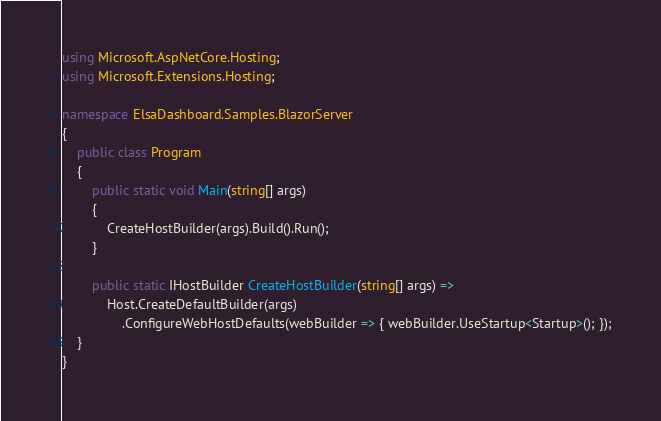Convert code to text. <code><loc_0><loc_0><loc_500><loc_500><_C#_>using Microsoft.AspNetCore.Hosting;
using Microsoft.Extensions.Hosting;

namespace ElsaDashboard.Samples.BlazorServer
{
    public class Program
    {
        public static void Main(string[] args)
        {
            CreateHostBuilder(args).Build().Run();
        }

        public static IHostBuilder CreateHostBuilder(string[] args) =>
            Host.CreateDefaultBuilder(args)
                .ConfigureWebHostDefaults(webBuilder => { webBuilder.UseStartup<Startup>(); });
    }
}</code> 